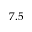Convert formula to latex. <formula><loc_0><loc_0><loc_500><loc_500>7 . 5</formula> 